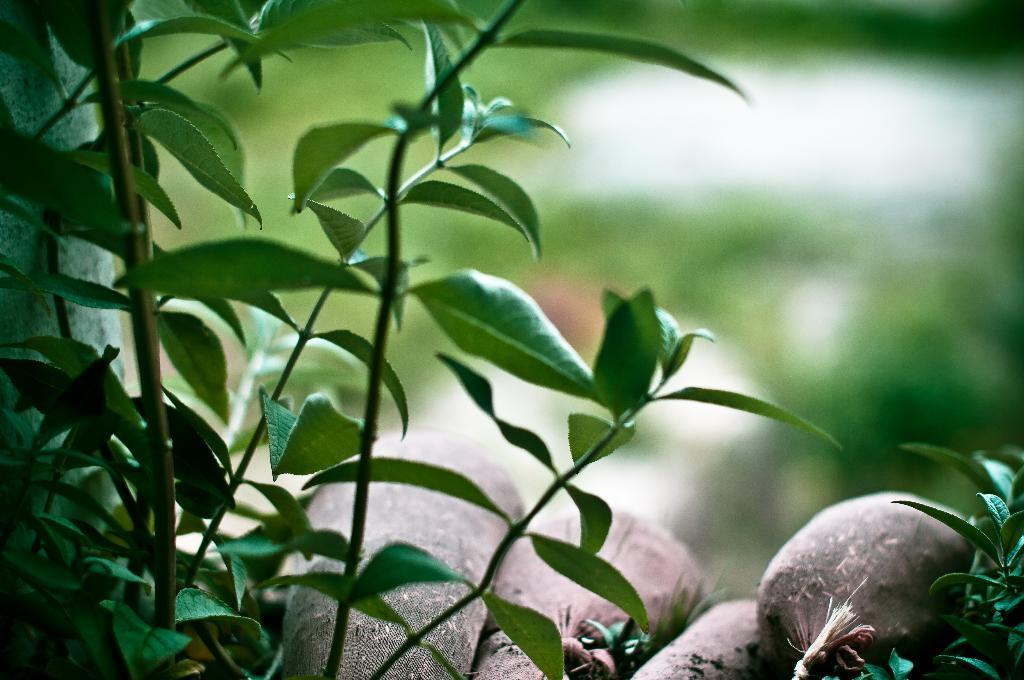What type of plant parts can be seen in the image? There are leaves and stems in the image. What color is the brown-colored object in the image? The brown-colored object in the image is not described in detail, so we cannot determine its exact color. How would you describe the background of the image? The background of the image is blurry. What type of office equipment can be seen in the image? There is no office equipment present in the image; it features leaves, stems, and a brown-colored object. Can you tell me which elbow is visible in the image? There are no elbows visible in the image; it features plant parts and a brown-colored object. 